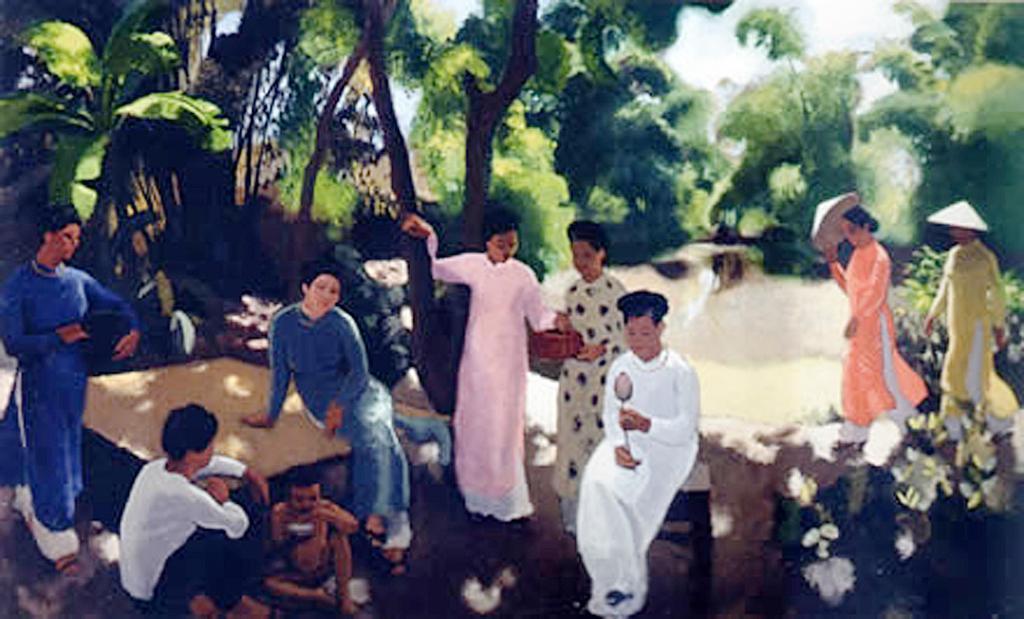Could you give a brief overview of what you see in this image? In this image we can see there is a painting of a few people sitting and standing, few are walking, there is a table, stool, trees, flowers and plants. 